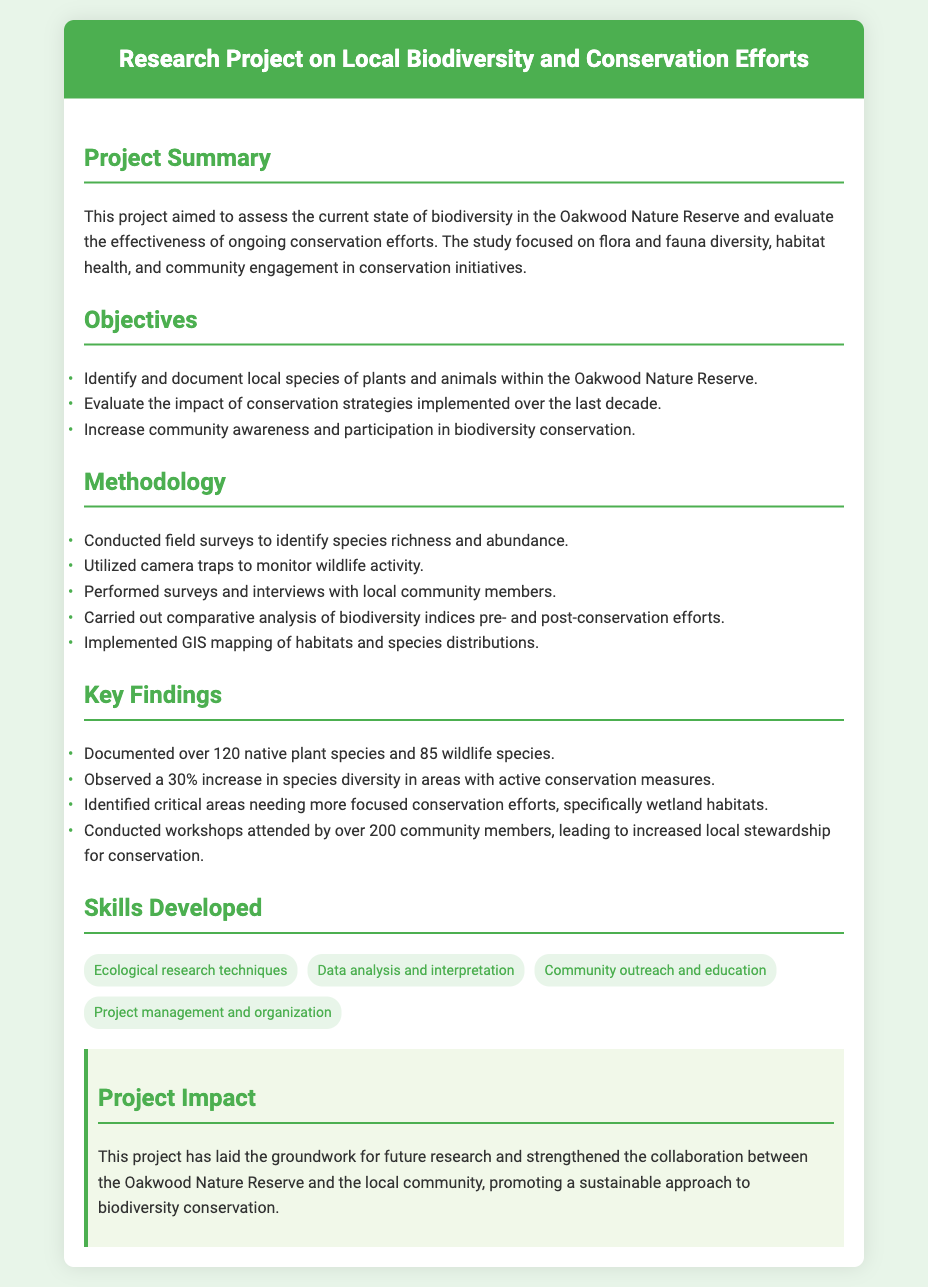What was the main aim of the project? The main aim of the project was to assess the current state of biodiversity in the Oakwood Nature Reserve and evaluate the effectiveness of ongoing conservation efforts.
Answer: Assess biodiversity How many native plant species were documented? The document states that over 120 native plant species were documented during the project.
Answer: Over 120 What percentage increase in species diversity was observed? The project observed a 30% increase in species diversity in areas with active conservation measures.
Answer: 30% What methods were used to monitor wildlife activity? Camera traps were utilized to monitor wildlife activity as mentioned in the methodology section.
Answer: Camera traps How many community members attended the workshops? The workshops conducted led to the attendance of over 200 community members, which highlights community engagement.
Answer: Over 200 Which critical habitats were identified as needing more focused conservation efforts? The document identifies wetland habitats as critical areas needing more focused conservation efforts.
Answer: Wetland habitats What skills were developed through the project? Skills developed included ecological research techniques, data analysis and interpretation, community outreach and education, and project management and organization.
Answer: Ecological research techniques, data analysis and interpretation, community outreach and education, project management and organization What type of document is this? This document is a resume about a research project on local biodiversity and conservation efforts.
Answer: Resume 